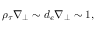Convert formula to latex. <formula><loc_0><loc_0><loc_500><loc_500>\rho _ { \tau } \nabla _ { \perp } \sim d _ { e } \nabla _ { \perp } \sim 1 ,</formula> 